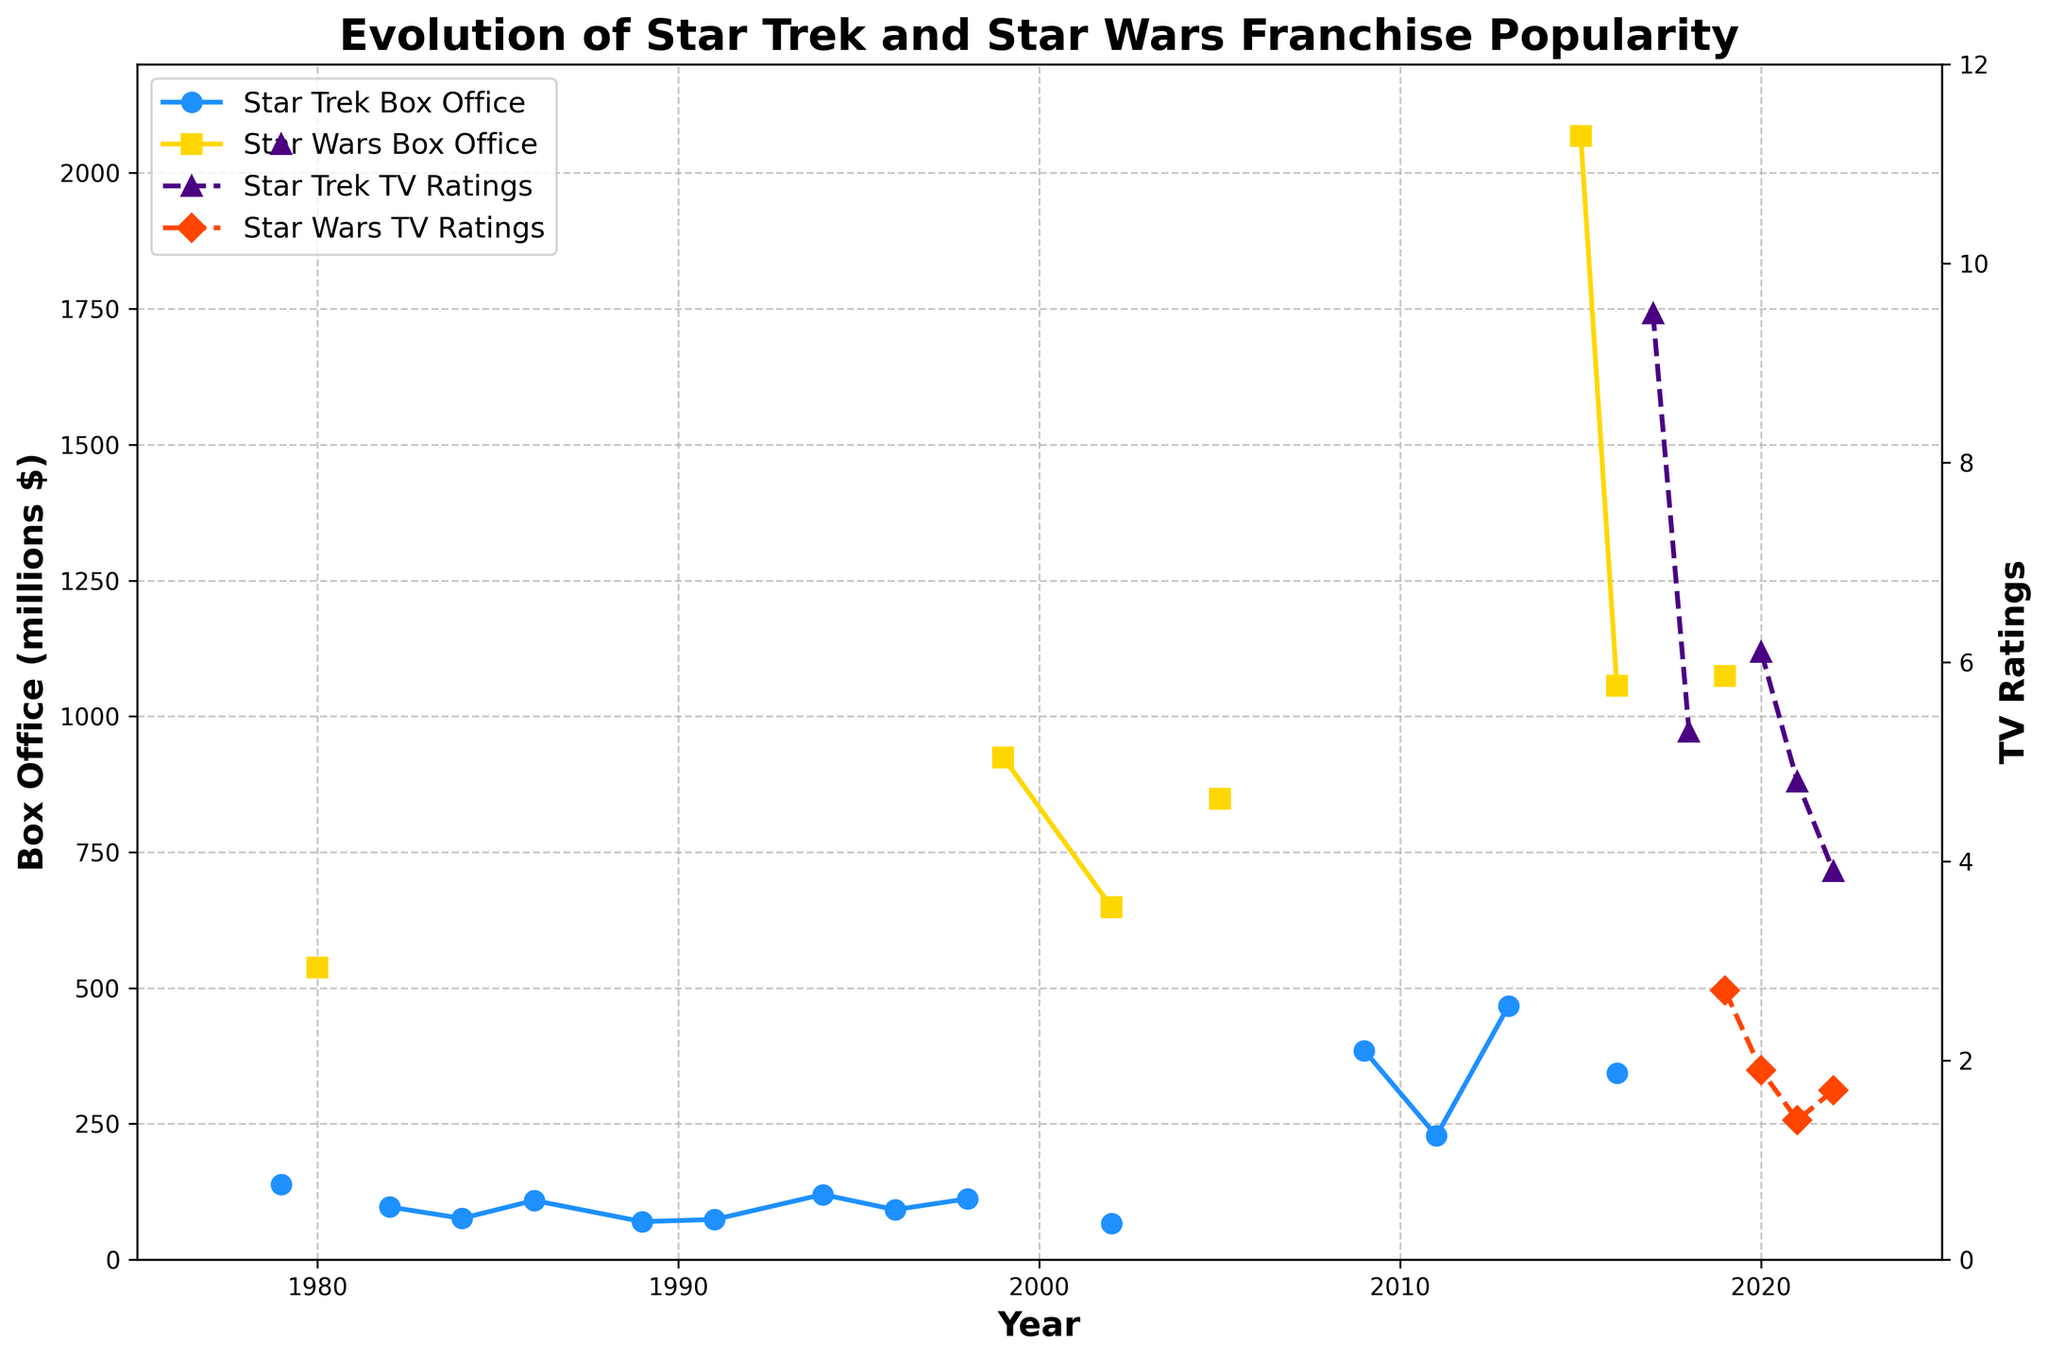Which franchise had the higher box office earnings in 1999? In 1999, the data shows Star Wars had box office earnings of 924 million while there is no data for Star Trek. Therefore, Star Wars earned more.
Answer: Star Wars What is the highest TV rating observed for Star Trek and in which year did it occur? The highest TV rating for Star Trek was 11.2 and it occurred in 1979.
Answer: 11.2 in 1979 Between 2015 and 2019, which year had the highest box office earnings for Star Wars? By observing the line representing Star Wars box office earnings between 2015 and 2019, the highest point is in 2015 with earnings of 2068 million.
Answer: 2015 How did Star Trek’s TV ratings change from 2017 to 2018? From the chart, Star Trek's TV ratings dropped from 9.5 in 2017 to 5.3 in 2018.
Answer: Decreased from 9.5 to 5.3 What is the sum of Star Trek’s box office earnings in the years 2009 and 2011? The box office earnings for Star Trek in 2009 is 385 million, and in 2011 it is 228 million. Sum: 385 + 228 = 613 million.
Answer: 613 million How many years recorded Star Trek TV ratings greater than 6.0? From the chart, Star Trek TV ratings greater than 6.0 appear in 1979 (11.2) and 2017 (9.5). Thus, it's 2 years.
Answer: 2 years Which has a higher TV rating in 2022, Star Trek or Star Wars? In 2022, Star Trek's TV rating is 3.9 and Star Wars' rating is 1.7. Star Trek’s rating is higher.
Answer: Star Trek What is the difference in box office earnings between Star Trek and Star Wars in 2016? In 2016, the box office earnings for Star Trek is 343 million and for Star Wars is 1056 million. Difference: 1056 - 343 = 713 million.
Answer: 713 million In which years did Star Trek have box office earnings but Star Wars did not? Years when Star Trek had box office earnings but Star Wars did not are 1979, 1982, 1984, 1986, 1989, 1991, 1994, 1996, 1998, 2002, 2009, 2011, 2013.
Answer: 13 years Which had a higher box office earning in 1980, Star Trek or Star Wars? The data shows that Star Wars had a box office earning of 538 million in 1980, while there is no data for Star Trek. Star Wars earned more.
Answer: Star Wars 